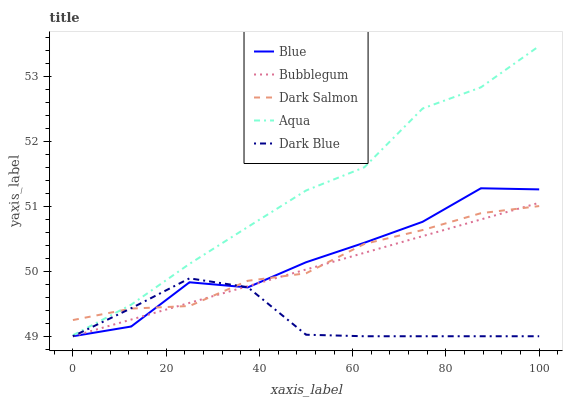Does Dark Blue have the minimum area under the curve?
Answer yes or no. Yes. Does Aqua have the maximum area under the curve?
Answer yes or no. Yes. Does Aqua have the minimum area under the curve?
Answer yes or no. No. Does Dark Blue have the maximum area under the curve?
Answer yes or no. No. Is Bubblegum the smoothest?
Answer yes or no. Yes. Is Blue the roughest?
Answer yes or no. Yes. Is Dark Blue the smoothest?
Answer yes or no. No. Is Dark Blue the roughest?
Answer yes or no. No. Does Aqua have the lowest value?
Answer yes or no. No. Does Aqua have the highest value?
Answer yes or no. Yes. Does Dark Blue have the highest value?
Answer yes or no. No. Is Bubblegum less than Aqua?
Answer yes or no. Yes. Is Aqua greater than Bubblegum?
Answer yes or no. Yes. Does Aqua intersect Dark Salmon?
Answer yes or no. Yes. Is Aqua less than Dark Salmon?
Answer yes or no. No. Is Aqua greater than Dark Salmon?
Answer yes or no. No. Does Bubblegum intersect Aqua?
Answer yes or no. No. 